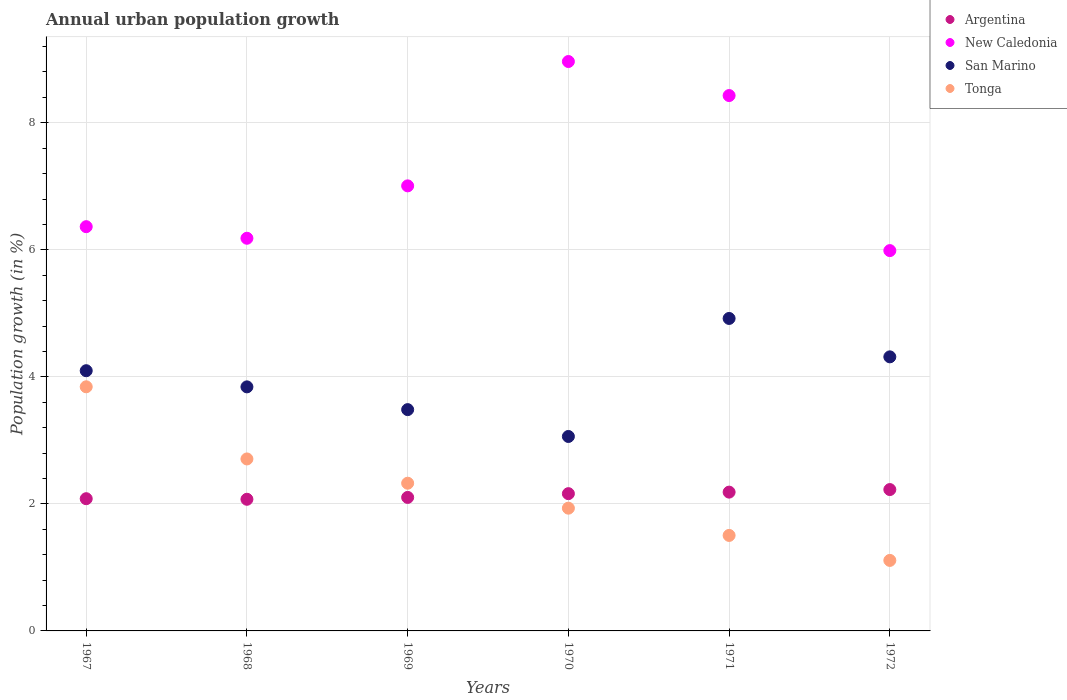Is the number of dotlines equal to the number of legend labels?
Make the answer very short. Yes. What is the percentage of urban population growth in Tonga in 1971?
Ensure brevity in your answer.  1.5. Across all years, what is the maximum percentage of urban population growth in Argentina?
Your response must be concise. 2.23. Across all years, what is the minimum percentage of urban population growth in Tonga?
Ensure brevity in your answer.  1.11. In which year was the percentage of urban population growth in Argentina maximum?
Your answer should be compact. 1972. In which year was the percentage of urban population growth in New Caledonia minimum?
Your answer should be compact. 1972. What is the total percentage of urban population growth in New Caledonia in the graph?
Make the answer very short. 42.93. What is the difference between the percentage of urban population growth in San Marino in 1968 and that in 1970?
Make the answer very short. 0.78. What is the difference between the percentage of urban population growth in New Caledonia in 1971 and the percentage of urban population growth in Argentina in 1970?
Provide a short and direct response. 6.27. What is the average percentage of urban population growth in Argentina per year?
Offer a terse response. 2.14. In the year 1968, what is the difference between the percentage of urban population growth in Tonga and percentage of urban population growth in Argentina?
Your response must be concise. 0.64. What is the ratio of the percentage of urban population growth in New Caledonia in 1968 to that in 1971?
Provide a short and direct response. 0.73. Is the percentage of urban population growth in Argentina in 1968 less than that in 1972?
Give a very brief answer. Yes. Is the difference between the percentage of urban population growth in Tonga in 1967 and 1970 greater than the difference between the percentage of urban population growth in Argentina in 1967 and 1970?
Make the answer very short. Yes. What is the difference between the highest and the second highest percentage of urban population growth in San Marino?
Offer a very short reply. 0.6. What is the difference between the highest and the lowest percentage of urban population growth in Tonga?
Your answer should be very brief. 2.73. In how many years, is the percentage of urban population growth in New Caledonia greater than the average percentage of urban population growth in New Caledonia taken over all years?
Your answer should be compact. 2. Is it the case that in every year, the sum of the percentage of urban population growth in San Marino and percentage of urban population growth in New Caledonia  is greater than the percentage of urban population growth in Argentina?
Your answer should be compact. Yes. Does the percentage of urban population growth in Tonga monotonically increase over the years?
Your response must be concise. No. Is the percentage of urban population growth in New Caledonia strictly greater than the percentage of urban population growth in San Marino over the years?
Your answer should be compact. Yes. What is the difference between two consecutive major ticks on the Y-axis?
Make the answer very short. 2. Are the values on the major ticks of Y-axis written in scientific E-notation?
Your answer should be very brief. No. Does the graph contain any zero values?
Your answer should be compact. No. Does the graph contain grids?
Your answer should be compact. Yes. Where does the legend appear in the graph?
Make the answer very short. Top right. How many legend labels are there?
Provide a short and direct response. 4. What is the title of the graph?
Offer a terse response. Annual urban population growth. What is the label or title of the Y-axis?
Ensure brevity in your answer.  Population growth (in %). What is the Population growth (in %) in Argentina in 1967?
Provide a succinct answer. 2.08. What is the Population growth (in %) of New Caledonia in 1967?
Give a very brief answer. 6.36. What is the Population growth (in %) of San Marino in 1967?
Offer a very short reply. 4.1. What is the Population growth (in %) of Tonga in 1967?
Your response must be concise. 3.84. What is the Population growth (in %) in Argentina in 1968?
Provide a short and direct response. 2.07. What is the Population growth (in %) in New Caledonia in 1968?
Your answer should be compact. 6.18. What is the Population growth (in %) of San Marino in 1968?
Keep it short and to the point. 3.84. What is the Population growth (in %) of Tonga in 1968?
Offer a very short reply. 2.71. What is the Population growth (in %) in Argentina in 1969?
Your response must be concise. 2.1. What is the Population growth (in %) of New Caledonia in 1969?
Ensure brevity in your answer.  7.01. What is the Population growth (in %) of San Marino in 1969?
Ensure brevity in your answer.  3.48. What is the Population growth (in %) in Tonga in 1969?
Offer a terse response. 2.33. What is the Population growth (in %) in Argentina in 1970?
Make the answer very short. 2.16. What is the Population growth (in %) in New Caledonia in 1970?
Provide a succinct answer. 8.96. What is the Population growth (in %) in San Marino in 1970?
Provide a short and direct response. 3.06. What is the Population growth (in %) in Tonga in 1970?
Provide a succinct answer. 1.93. What is the Population growth (in %) in Argentina in 1971?
Keep it short and to the point. 2.19. What is the Population growth (in %) of New Caledonia in 1971?
Provide a short and direct response. 8.43. What is the Population growth (in %) of San Marino in 1971?
Provide a succinct answer. 4.92. What is the Population growth (in %) of Tonga in 1971?
Give a very brief answer. 1.5. What is the Population growth (in %) of Argentina in 1972?
Ensure brevity in your answer.  2.23. What is the Population growth (in %) of New Caledonia in 1972?
Provide a short and direct response. 5.99. What is the Population growth (in %) of San Marino in 1972?
Your answer should be very brief. 4.31. What is the Population growth (in %) in Tonga in 1972?
Your response must be concise. 1.11. Across all years, what is the maximum Population growth (in %) of Argentina?
Provide a short and direct response. 2.23. Across all years, what is the maximum Population growth (in %) in New Caledonia?
Provide a short and direct response. 8.96. Across all years, what is the maximum Population growth (in %) of San Marino?
Your answer should be compact. 4.92. Across all years, what is the maximum Population growth (in %) of Tonga?
Ensure brevity in your answer.  3.84. Across all years, what is the minimum Population growth (in %) of Argentina?
Your response must be concise. 2.07. Across all years, what is the minimum Population growth (in %) in New Caledonia?
Your answer should be very brief. 5.99. Across all years, what is the minimum Population growth (in %) in San Marino?
Give a very brief answer. 3.06. Across all years, what is the minimum Population growth (in %) in Tonga?
Make the answer very short. 1.11. What is the total Population growth (in %) in Argentina in the graph?
Make the answer very short. 12.83. What is the total Population growth (in %) in New Caledonia in the graph?
Provide a succinct answer. 42.93. What is the total Population growth (in %) in San Marino in the graph?
Offer a very short reply. 23.72. What is the total Population growth (in %) of Tonga in the graph?
Offer a very short reply. 13.42. What is the difference between the Population growth (in %) in Argentina in 1967 and that in 1968?
Your answer should be compact. 0.01. What is the difference between the Population growth (in %) of New Caledonia in 1967 and that in 1968?
Make the answer very short. 0.18. What is the difference between the Population growth (in %) in San Marino in 1967 and that in 1968?
Ensure brevity in your answer.  0.25. What is the difference between the Population growth (in %) in Tonga in 1967 and that in 1968?
Provide a succinct answer. 1.14. What is the difference between the Population growth (in %) of Argentina in 1967 and that in 1969?
Offer a very short reply. -0.02. What is the difference between the Population growth (in %) of New Caledonia in 1967 and that in 1969?
Provide a short and direct response. -0.64. What is the difference between the Population growth (in %) in San Marino in 1967 and that in 1969?
Offer a terse response. 0.61. What is the difference between the Population growth (in %) in Tonga in 1967 and that in 1969?
Make the answer very short. 1.52. What is the difference between the Population growth (in %) in Argentina in 1967 and that in 1970?
Your answer should be very brief. -0.08. What is the difference between the Population growth (in %) in New Caledonia in 1967 and that in 1970?
Provide a short and direct response. -2.6. What is the difference between the Population growth (in %) of San Marino in 1967 and that in 1970?
Keep it short and to the point. 1.04. What is the difference between the Population growth (in %) in Tonga in 1967 and that in 1970?
Ensure brevity in your answer.  1.91. What is the difference between the Population growth (in %) of Argentina in 1967 and that in 1971?
Keep it short and to the point. -0.1. What is the difference between the Population growth (in %) of New Caledonia in 1967 and that in 1971?
Offer a very short reply. -2.06. What is the difference between the Population growth (in %) in San Marino in 1967 and that in 1971?
Your answer should be compact. -0.82. What is the difference between the Population growth (in %) in Tonga in 1967 and that in 1971?
Your answer should be compact. 2.34. What is the difference between the Population growth (in %) of Argentina in 1967 and that in 1972?
Your answer should be very brief. -0.14. What is the difference between the Population growth (in %) in New Caledonia in 1967 and that in 1972?
Offer a terse response. 0.38. What is the difference between the Population growth (in %) of San Marino in 1967 and that in 1972?
Your response must be concise. -0.22. What is the difference between the Population growth (in %) of Tonga in 1967 and that in 1972?
Offer a terse response. 2.73. What is the difference between the Population growth (in %) in Argentina in 1968 and that in 1969?
Your answer should be compact. -0.03. What is the difference between the Population growth (in %) of New Caledonia in 1968 and that in 1969?
Ensure brevity in your answer.  -0.82. What is the difference between the Population growth (in %) in San Marino in 1968 and that in 1969?
Give a very brief answer. 0.36. What is the difference between the Population growth (in %) of Tonga in 1968 and that in 1969?
Give a very brief answer. 0.38. What is the difference between the Population growth (in %) of Argentina in 1968 and that in 1970?
Offer a very short reply. -0.09. What is the difference between the Population growth (in %) in New Caledonia in 1968 and that in 1970?
Your answer should be compact. -2.78. What is the difference between the Population growth (in %) of San Marino in 1968 and that in 1970?
Your response must be concise. 0.78. What is the difference between the Population growth (in %) of Tonga in 1968 and that in 1970?
Provide a succinct answer. 0.78. What is the difference between the Population growth (in %) in Argentina in 1968 and that in 1971?
Your answer should be compact. -0.11. What is the difference between the Population growth (in %) in New Caledonia in 1968 and that in 1971?
Make the answer very short. -2.25. What is the difference between the Population growth (in %) of San Marino in 1968 and that in 1971?
Your answer should be compact. -1.08. What is the difference between the Population growth (in %) in Tonga in 1968 and that in 1971?
Ensure brevity in your answer.  1.2. What is the difference between the Population growth (in %) of Argentina in 1968 and that in 1972?
Keep it short and to the point. -0.15. What is the difference between the Population growth (in %) in New Caledonia in 1968 and that in 1972?
Your answer should be compact. 0.19. What is the difference between the Population growth (in %) of San Marino in 1968 and that in 1972?
Your answer should be compact. -0.47. What is the difference between the Population growth (in %) in Tonga in 1968 and that in 1972?
Keep it short and to the point. 1.6. What is the difference between the Population growth (in %) of Argentina in 1969 and that in 1970?
Offer a terse response. -0.06. What is the difference between the Population growth (in %) of New Caledonia in 1969 and that in 1970?
Your response must be concise. -1.96. What is the difference between the Population growth (in %) of San Marino in 1969 and that in 1970?
Give a very brief answer. 0.42. What is the difference between the Population growth (in %) of Tonga in 1969 and that in 1970?
Your answer should be compact. 0.39. What is the difference between the Population growth (in %) in Argentina in 1969 and that in 1971?
Provide a short and direct response. -0.08. What is the difference between the Population growth (in %) of New Caledonia in 1969 and that in 1971?
Give a very brief answer. -1.42. What is the difference between the Population growth (in %) in San Marino in 1969 and that in 1971?
Keep it short and to the point. -1.44. What is the difference between the Population growth (in %) of Tonga in 1969 and that in 1971?
Your response must be concise. 0.82. What is the difference between the Population growth (in %) in Argentina in 1969 and that in 1972?
Your answer should be compact. -0.12. What is the difference between the Population growth (in %) in New Caledonia in 1969 and that in 1972?
Offer a very short reply. 1.02. What is the difference between the Population growth (in %) of San Marino in 1969 and that in 1972?
Provide a short and direct response. -0.83. What is the difference between the Population growth (in %) in Tonga in 1969 and that in 1972?
Your answer should be very brief. 1.22. What is the difference between the Population growth (in %) of Argentina in 1970 and that in 1971?
Give a very brief answer. -0.02. What is the difference between the Population growth (in %) of New Caledonia in 1970 and that in 1971?
Your response must be concise. 0.54. What is the difference between the Population growth (in %) of San Marino in 1970 and that in 1971?
Provide a short and direct response. -1.86. What is the difference between the Population growth (in %) of Tonga in 1970 and that in 1971?
Ensure brevity in your answer.  0.43. What is the difference between the Population growth (in %) in Argentina in 1970 and that in 1972?
Your response must be concise. -0.06. What is the difference between the Population growth (in %) of New Caledonia in 1970 and that in 1972?
Your answer should be compact. 2.98. What is the difference between the Population growth (in %) of San Marino in 1970 and that in 1972?
Offer a very short reply. -1.25. What is the difference between the Population growth (in %) of Tonga in 1970 and that in 1972?
Ensure brevity in your answer.  0.82. What is the difference between the Population growth (in %) in Argentina in 1971 and that in 1972?
Make the answer very short. -0.04. What is the difference between the Population growth (in %) of New Caledonia in 1971 and that in 1972?
Give a very brief answer. 2.44. What is the difference between the Population growth (in %) of San Marino in 1971 and that in 1972?
Your response must be concise. 0.6. What is the difference between the Population growth (in %) in Tonga in 1971 and that in 1972?
Your answer should be compact. 0.39. What is the difference between the Population growth (in %) of Argentina in 1967 and the Population growth (in %) of New Caledonia in 1968?
Make the answer very short. -4.1. What is the difference between the Population growth (in %) in Argentina in 1967 and the Population growth (in %) in San Marino in 1968?
Make the answer very short. -1.76. What is the difference between the Population growth (in %) in Argentina in 1967 and the Population growth (in %) in Tonga in 1968?
Ensure brevity in your answer.  -0.63. What is the difference between the Population growth (in %) of New Caledonia in 1967 and the Population growth (in %) of San Marino in 1968?
Your answer should be very brief. 2.52. What is the difference between the Population growth (in %) of New Caledonia in 1967 and the Population growth (in %) of Tonga in 1968?
Ensure brevity in your answer.  3.66. What is the difference between the Population growth (in %) in San Marino in 1967 and the Population growth (in %) in Tonga in 1968?
Provide a short and direct response. 1.39. What is the difference between the Population growth (in %) in Argentina in 1967 and the Population growth (in %) in New Caledonia in 1969?
Offer a terse response. -4.93. What is the difference between the Population growth (in %) in Argentina in 1967 and the Population growth (in %) in San Marino in 1969?
Offer a very short reply. -1.4. What is the difference between the Population growth (in %) of Argentina in 1967 and the Population growth (in %) of Tonga in 1969?
Make the answer very short. -0.24. What is the difference between the Population growth (in %) of New Caledonia in 1967 and the Population growth (in %) of San Marino in 1969?
Make the answer very short. 2.88. What is the difference between the Population growth (in %) of New Caledonia in 1967 and the Population growth (in %) of Tonga in 1969?
Your answer should be compact. 4.04. What is the difference between the Population growth (in %) in San Marino in 1967 and the Population growth (in %) in Tonga in 1969?
Keep it short and to the point. 1.77. What is the difference between the Population growth (in %) of Argentina in 1967 and the Population growth (in %) of New Caledonia in 1970?
Give a very brief answer. -6.88. What is the difference between the Population growth (in %) in Argentina in 1967 and the Population growth (in %) in San Marino in 1970?
Make the answer very short. -0.98. What is the difference between the Population growth (in %) in Argentina in 1967 and the Population growth (in %) in Tonga in 1970?
Provide a succinct answer. 0.15. What is the difference between the Population growth (in %) of New Caledonia in 1967 and the Population growth (in %) of San Marino in 1970?
Ensure brevity in your answer.  3.3. What is the difference between the Population growth (in %) in New Caledonia in 1967 and the Population growth (in %) in Tonga in 1970?
Keep it short and to the point. 4.43. What is the difference between the Population growth (in %) in San Marino in 1967 and the Population growth (in %) in Tonga in 1970?
Ensure brevity in your answer.  2.16. What is the difference between the Population growth (in %) of Argentina in 1967 and the Population growth (in %) of New Caledonia in 1971?
Keep it short and to the point. -6.35. What is the difference between the Population growth (in %) of Argentina in 1967 and the Population growth (in %) of San Marino in 1971?
Your answer should be very brief. -2.84. What is the difference between the Population growth (in %) of Argentina in 1967 and the Population growth (in %) of Tonga in 1971?
Make the answer very short. 0.58. What is the difference between the Population growth (in %) in New Caledonia in 1967 and the Population growth (in %) in San Marino in 1971?
Provide a short and direct response. 1.44. What is the difference between the Population growth (in %) of New Caledonia in 1967 and the Population growth (in %) of Tonga in 1971?
Provide a succinct answer. 4.86. What is the difference between the Population growth (in %) in San Marino in 1967 and the Population growth (in %) in Tonga in 1971?
Provide a succinct answer. 2.59. What is the difference between the Population growth (in %) in Argentina in 1967 and the Population growth (in %) in New Caledonia in 1972?
Offer a very short reply. -3.91. What is the difference between the Population growth (in %) of Argentina in 1967 and the Population growth (in %) of San Marino in 1972?
Offer a terse response. -2.23. What is the difference between the Population growth (in %) of Argentina in 1967 and the Population growth (in %) of Tonga in 1972?
Make the answer very short. 0.97. What is the difference between the Population growth (in %) in New Caledonia in 1967 and the Population growth (in %) in San Marino in 1972?
Make the answer very short. 2.05. What is the difference between the Population growth (in %) in New Caledonia in 1967 and the Population growth (in %) in Tonga in 1972?
Your answer should be compact. 5.25. What is the difference between the Population growth (in %) of San Marino in 1967 and the Population growth (in %) of Tonga in 1972?
Provide a succinct answer. 2.99. What is the difference between the Population growth (in %) of Argentina in 1968 and the Population growth (in %) of New Caledonia in 1969?
Provide a short and direct response. -4.93. What is the difference between the Population growth (in %) of Argentina in 1968 and the Population growth (in %) of San Marino in 1969?
Offer a very short reply. -1.41. What is the difference between the Population growth (in %) in Argentina in 1968 and the Population growth (in %) in Tonga in 1969?
Offer a very short reply. -0.25. What is the difference between the Population growth (in %) of New Caledonia in 1968 and the Population growth (in %) of San Marino in 1969?
Offer a terse response. 2.7. What is the difference between the Population growth (in %) of New Caledonia in 1968 and the Population growth (in %) of Tonga in 1969?
Offer a terse response. 3.86. What is the difference between the Population growth (in %) of San Marino in 1968 and the Population growth (in %) of Tonga in 1969?
Give a very brief answer. 1.52. What is the difference between the Population growth (in %) of Argentina in 1968 and the Population growth (in %) of New Caledonia in 1970?
Provide a short and direct response. -6.89. What is the difference between the Population growth (in %) of Argentina in 1968 and the Population growth (in %) of San Marino in 1970?
Provide a short and direct response. -0.99. What is the difference between the Population growth (in %) of Argentina in 1968 and the Population growth (in %) of Tonga in 1970?
Keep it short and to the point. 0.14. What is the difference between the Population growth (in %) in New Caledonia in 1968 and the Population growth (in %) in San Marino in 1970?
Ensure brevity in your answer.  3.12. What is the difference between the Population growth (in %) in New Caledonia in 1968 and the Population growth (in %) in Tonga in 1970?
Keep it short and to the point. 4.25. What is the difference between the Population growth (in %) in San Marino in 1968 and the Population growth (in %) in Tonga in 1970?
Offer a very short reply. 1.91. What is the difference between the Population growth (in %) in Argentina in 1968 and the Population growth (in %) in New Caledonia in 1971?
Offer a terse response. -6.36. What is the difference between the Population growth (in %) of Argentina in 1968 and the Population growth (in %) of San Marino in 1971?
Your answer should be very brief. -2.85. What is the difference between the Population growth (in %) of Argentina in 1968 and the Population growth (in %) of Tonga in 1971?
Offer a very short reply. 0.57. What is the difference between the Population growth (in %) of New Caledonia in 1968 and the Population growth (in %) of San Marino in 1971?
Make the answer very short. 1.26. What is the difference between the Population growth (in %) in New Caledonia in 1968 and the Population growth (in %) in Tonga in 1971?
Keep it short and to the point. 4.68. What is the difference between the Population growth (in %) of San Marino in 1968 and the Population growth (in %) of Tonga in 1971?
Ensure brevity in your answer.  2.34. What is the difference between the Population growth (in %) of Argentina in 1968 and the Population growth (in %) of New Caledonia in 1972?
Your answer should be very brief. -3.92. What is the difference between the Population growth (in %) in Argentina in 1968 and the Population growth (in %) in San Marino in 1972?
Provide a succinct answer. -2.24. What is the difference between the Population growth (in %) in Argentina in 1968 and the Population growth (in %) in Tonga in 1972?
Give a very brief answer. 0.96. What is the difference between the Population growth (in %) of New Caledonia in 1968 and the Population growth (in %) of San Marino in 1972?
Give a very brief answer. 1.87. What is the difference between the Population growth (in %) of New Caledonia in 1968 and the Population growth (in %) of Tonga in 1972?
Provide a succinct answer. 5.07. What is the difference between the Population growth (in %) in San Marino in 1968 and the Population growth (in %) in Tonga in 1972?
Your answer should be compact. 2.73. What is the difference between the Population growth (in %) in Argentina in 1969 and the Population growth (in %) in New Caledonia in 1970?
Offer a very short reply. -6.86. What is the difference between the Population growth (in %) in Argentina in 1969 and the Population growth (in %) in San Marino in 1970?
Make the answer very short. -0.96. What is the difference between the Population growth (in %) of Argentina in 1969 and the Population growth (in %) of Tonga in 1970?
Make the answer very short. 0.17. What is the difference between the Population growth (in %) of New Caledonia in 1969 and the Population growth (in %) of San Marino in 1970?
Offer a terse response. 3.95. What is the difference between the Population growth (in %) of New Caledonia in 1969 and the Population growth (in %) of Tonga in 1970?
Provide a succinct answer. 5.07. What is the difference between the Population growth (in %) in San Marino in 1969 and the Population growth (in %) in Tonga in 1970?
Keep it short and to the point. 1.55. What is the difference between the Population growth (in %) in Argentina in 1969 and the Population growth (in %) in New Caledonia in 1971?
Give a very brief answer. -6.33. What is the difference between the Population growth (in %) of Argentina in 1969 and the Population growth (in %) of San Marino in 1971?
Give a very brief answer. -2.82. What is the difference between the Population growth (in %) of Argentina in 1969 and the Population growth (in %) of Tonga in 1971?
Your response must be concise. 0.6. What is the difference between the Population growth (in %) of New Caledonia in 1969 and the Population growth (in %) of San Marino in 1971?
Your response must be concise. 2.09. What is the difference between the Population growth (in %) of New Caledonia in 1969 and the Population growth (in %) of Tonga in 1971?
Offer a terse response. 5.5. What is the difference between the Population growth (in %) in San Marino in 1969 and the Population growth (in %) in Tonga in 1971?
Keep it short and to the point. 1.98. What is the difference between the Population growth (in %) in Argentina in 1969 and the Population growth (in %) in New Caledonia in 1972?
Provide a short and direct response. -3.89. What is the difference between the Population growth (in %) in Argentina in 1969 and the Population growth (in %) in San Marino in 1972?
Provide a succinct answer. -2.21. What is the difference between the Population growth (in %) of Argentina in 1969 and the Population growth (in %) of Tonga in 1972?
Keep it short and to the point. 0.99. What is the difference between the Population growth (in %) of New Caledonia in 1969 and the Population growth (in %) of San Marino in 1972?
Give a very brief answer. 2.69. What is the difference between the Population growth (in %) in New Caledonia in 1969 and the Population growth (in %) in Tonga in 1972?
Your answer should be very brief. 5.9. What is the difference between the Population growth (in %) in San Marino in 1969 and the Population growth (in %) in Tonga in 1972?
Make the answer very short. 2.37. What is the difference between the Population growth (in %) of Argentina in 1970 and the Population growth (in %) of New Caledonia in 1971?
Keep it short and to the point. -6.27. What is the difference between the Population growth (in %) of Argentina in 1970 and the Population growth (in %) of San Marino in 1971?
Make the answer very short. -2.76. What is the difference between the Population growth (in %) in Argentina in 1970 and the Population growth (in %) in Tonga in 1971?
Your answer should be very brief. 0.66. What is the difference between the Population growth (in %) in New Caledonia in 1970 and the Population growth (in %) in San Marino in 1971?
Provide a short and direct response. 4.05. What is the difference between the Population growth (in %) of New Caledonia in 1970 and the Population growth (in %) of Tonga in 1971?
Offer a very short reply. 7.46. What is the difference between the Population growth (in %) of San Marino in 1970 and the Population growth (in %) of Tonga in 1971?
Your answer should be very brief. 1.56. What is the difference between the Population growth (in %) in Argentina in 1970 and the Population growth (in %) in New Caledonia in 1972?
Provide a succinct answer. -3.83. What is the difference between the Population growth (in %) in Argentina in 1970 and the Population growth (in %) in San Marino in 1972?
Provide a succinct answer. -2.15. What is the difference between the Population growth (in %) of Argentina in 1970 and the Population growth (in %) of Tonga in 1972?
Ensure brevity in your answer.  1.05. What is the difference between the Population growth (in %) in New Caledonia in 1970 and the Population growth (in %) in San Marino in 1972?
Keep it short and to the point. 4.65. What is the difference between the Population growth (in %) of New Caledonia in 1970 and the Population growth (in %) of Tonga in 1972?
Provide a succinct answer. 7.85. What is the difference between the Population growth (in %) in San Marino in 1970 and the Population growth (in %) in Tonga in 1972?
Keep it short and to the point. 1.95. What is the difference between the Population growth (in %) in Argentina in 1971 and the Population growth (in %) in New Caledonia in 1972?
Make the answer very short. -3.8. What is the difference between the Population growth (in %) of Argentina in 1971 and the Population growth (in %) of San Marino in 1972?
Provide a short and direct response. -2.13. What is the difference between the Population growth (in %) in Argentina in 1971 and the Population growth (in %) in Tonga in 1972?
Your answer should be very brief. 1.08. What is the difference between the Population growth (in %) of New Caledonia in 1971 and the Population growth (in %) of San Marino in 1972?
Give a very brief answer. 4.11. What is the difference between the Population growth (in %) in New Caledonia in 1971 and the Population growth (in %) in Tonga in 1972?
Ensure brevity in your answer.  7.32. What is the difference between the Population growth (in %) of San Marino in 1971 and the Population growth (in %) of Tonga in 1972?
Ensure brevity in your answer.  3.81. What is the average Population growth (in %) in Argentina per year?
Keep it short and to the point. 2.14. What is the average Population growth (in %) of New Caledonia per year?
Provide a short and direct response. 7.16. What is the average Population growth (in %) in San Marino per year?
Offer a very short reply. 3.95. What is the average Population growth (in %) of Tonga per year?
Ensure brevity in your answer.  2.24. In the year 1967, what is the difference between the Population growth (in %) of Argentina and Population growth (in %) of New Caledonia?
Make the answer very short. -4.28. In the year 1967, what is the difference between the Population growth (in %) of Argentina and Population growth (in %) of San Marino?
Provide a succinct answer. -2.02. In the year 1967, what is the difference between the Population growth (in %) in Argentina and Population growth (in %) in Tonga?
Your response must be concise. -1.76. In the year 1967, what is the difference between the Population growth (in %) of New Caledonia and Population growth (in %) of San Marino?
Your response must be concise. 2.27. In the year 1967, what is the difference between the Population growth (in %) of New Caledonia and Population growth (in %) of Tonga?
Give a very brief answer. 2.52. In the year 1967, what is the difference between the Population growth (in %) in San Marino and Population growth (in %) in Tonga?
Give a very brief answer. 0.25. In the year 1968, what is the difference between the Population growth (in %) in Argentina and Population growth (in %) in New Caledonia?
Give a very brief answer. -4.11. In the year 1968, what is the difference between the Population growth (in %) in Argentina and Population growth (in %) in San Marino?
Give a very brief answer. -1.77. In the year 1968, what is the difference between the Population growth (in %) of Argentina and Population growth (in %) of Tonga?
Offer a very short reply. -0.64. In the year 1968, what is the difference between the Population growth (in %) in New Caledonia and Population growth (in %) in San Marino?
Provide a short and direct response. 2.34. In the year 1968, what is the difference between the Population growth (in %) in New Caledonia and Population growth (in %) in Tonga?
Give a very brief answer. 3.47. In the year 1968, what is the difference between the Population growth (in %) of San Marino and Population growth (in %) of Tonga?
Your answer should be very brief. 1.13. In the year 1969, what is the difference between the Population growth (in %) of Argentina and Population growth (in %) of New Caledonia?
Keep it short and to the point. -4.91. In the year 1969, what is the difference between the Population growth (in %) in Argentina and Population growth (in %) in San Marino?
Provide a succinct answer. -1.38. In the year 1969, what is the difference between the Population growth (in %) in Argentina and Population growth (in %) in Tonga?
Ensure brevity in your answer.  -0.22. In the year 1969, what is the difference between the Population growth (in %) in New Caledonia and Population growth (in %) in San Marino?
Your answer should be compact. 3.52. In the year 1969, what is the difference between the Population growth (in %) of New Caledonia and Population growth (in %) of Tonga?
Ensure brevity in your answer.  4.68. In the year 1969, what is the difference between the Population growth (in %) of San Marino and Population growth (in %) of Tonga?
Provide a succinct answer. 1.16. In the year 1970, what is the difference between the Population growth (in %) of Argentina and Population growth (in %) of New Caledonia?
Ensure brevity in your answer.  -6.8. In the year 1970, what is the difference between the Population growth (in %) in Argentina and Population growth (in %) in San Marino?
Provide a succinct answer. -0.9. In the year 1970, what is the difference between the Population growth (in %) of Argentina and Population growth (in %) of Tonga?
Make the answer very short. 0.23. In the year 1970, what is the difference between the Population growth (in %) in New Caledonia and Population growth (in %) in San Marino?
Make the answer very short. 5.9. In the year 1970, what is the difference between the Population growth (in %) in New Caledonia and Population growth (in %) in Tonga?
Your answer should be compact. 7.03. In the year 1970, what is the difference between the Population growth (in %) of San Marino and Population growth (in %) of Tonga?
Your answer should be compact. 1.13. In the year 1971, what is the difference between the Population growth (in %) in Argentina and Population growth (in %) in New Caledonia?
Give a very brief answer. -6.24. In the year 1971, what is the difference between the Population growth (in %) in Argentina and Population growth (in %) in San Marino?
Ensure brevity in your answer.  -2.73. In the year 1971, what is the difference between the Population growth (in %) in Argentina and Population growth (in %) in Tonga?
Your response must be concise. 0.68. In the year 1971, what is the difference between the Population growth (in %) in New Caledonia and Population growth (in %) in San Marino?
Keep it short and to the point. 3.51. In the year 1971, what is the difference between the Population growth (in %) of New Caledonia and Population growth (in %) of Tonga?
Your answer should be very brief. 6.93. In the year 1971, what is the difference between the Population growth (in %) of San Marino and Population growth (in %) of Tonga?
Ensure brevity in your answer.  3.42. In the year 1972, what is the difference between the Population growth (in %) of Argentina and Population growth (in %) of New Caledonia?
Ensure brevity in your answer.  -3.76. In the year 1972, what is the difference between the Population growth (in %) in Argentina and Population growth (in %) in San Marino?
Your answer should be compact. -2.09. In the year 1972, what is the difference between the Population growth (in %) in Argentina and Population growth (in %) in Tonga?
Give a very brief answer. 1.12. In the year 1972, what is the difference between the Population growth (in %) in New Caledonia and Population growth (in %) in San Marino?
Your response must be concise. 1.67. In the year 1972, what is the difference between the Population growth (in %) of New Caledonia and Population growth (in %) of Tonga?
Offer a terse response. 4.88. In the year 1972, what is the difference between the Population growth (in %) of San Marino and Population growth (in %) of Tonga?
Keep it short and to the point. 3.2. What is the ratio of the Population growth (in %) of New Caledonia in 1967 to that in 1968?
Your answer should be very brief. 1.03. What is the ratio of the Population growth (in %) of San Marino in 1967 to that in 1968?
Your response must be concise. 1.07. What is the ratio of the Population growth (in %) of Tonga in 1967 to that in 1968?
Offer a very short reply. 1.42. What is the ratio of the Population growth (in %) in Argentina in 1967 to that in 1969?
Your answer should be very brief. 0.99. What is the ratio of the Population growth (in %) of New Caledonia in 1967 to that in 1969?
Your answer should be compact. 0.91. What is the ratio of the Population growth (in %) of San Marino in 1967 to that in 1969?
Offer a very short reply. 1.18. What is the ratio of the Population growth (in %) in Tonga in 1967 to that in 1969?
Make the answer very short. 1.65. What is the ratio of the Population growth (in %) of Argentina in 1967 to that in 1970?
Ensure brevity in your answer.  0.96. What is the ratio of the Population growth (in %) in New Caledonia in 1967 to that in 1970?
Your answer should be compact. 0.71. What is the ratio of the Population growth (in %) in San Marino in 1967 to that in 1970?
Give a very brief answer. 1.34. What is the ratio of the Population growth (in %) of Tonga in 1967 to that in 1970?
Your answer should be compact. 1.99. What is the ratio of the Population growth (in %) of Argentina in 1967 to that in 1971?
Give a very brief answer. 0.95. What is the ratio of the Population growth (in %) of New Caledonia in 1967 to that in 1971?
Provide a short and direct response. 0.76. What is the ratio of the Population growth (in %) of San Marino in 1967 to that in 1971?
Ensure brevity in your answer.  0.83. What is the ratio of the Population growth (in %) of Tonga in 1967 to that in 1971?
Your answer should be compact. 2.56. What is the ratio of the Population growth (in %) in Argentina in 1967 to that in 1972?
Make the answer very short. 0.94. What is the ratio of the Population growth (in %) in New Caledonia in 1967 to that in 1972?
Keep it short and to the point. 1.06. What is the ratio of the Population growth (in %) of San Marino in 1967 to that in 1972?
Keep it short and to the point. 0.95. What is the ratio of the Population growth (in %) of Tonga in 1967 to that in 1972?
Your answer should be very brief. 3.46. What is the ratio of the Population growth (in %) in Argentina in 1968 to that in 1969?
Offer a terse response. 0.99. What is the ratio of the Population growth (in %) in New Caledonia in 1968 to that in 1969?
Your response must be concise. 0.88. What is the ratio of the Population growth (in %) in San Marino in 1968 to that in 1969?
Ensure brevity in your answer.  1.1. What is the ratio of the Population growth (in %) in Tonga in 1968 to that in 1969?
Make the answer very short. 1.16. What is the ratio of the Population growth (in %) in Argentina in 1968 to that in 1970?
Provide a short and direct response. 0.96. What is the ratio of the Population growth (in %) of New Caledonia in 1968 to that in 1970?
Your answer should be very brief. 0.69. What is the ratio of the Population growth (in %) of San Marino in 1968 to that in 1970?
Your answer should be very brief. 1.26. What is the ratio of the Population growth (in %) in Tonga in 1968 to that in 1970?
Keep it short and to the point. 1.4. What is the ratio of the Population growth (in %) of Argentina in 1968 to that in 1971?
Provide a short and direct response. 0.95. What is the ratio of the Population growth (in %) in New Caledonia in 1968 to that in 1971?
Your response must be concise. 0.73. What is the ratio of the Population growth (in %) of San Marino in 1968 to that in 1971?
Provide a succinct answer. 0.78. What is the ratio of the Population growth (in %) in Tonga in 1968 to that in 1971?
Keep it short and to the point. 1.8. What is the ratio of the Population growth (in %) in Argentina in 1968 to that in 1972?
Keep it short and to the point. 0.93. What is the ratio of the Population growth (in %) of New Caledonia in 1968 to that in 1972?
Make the answer very short. 1.03. What is the ratio of the Population growth (in %) of San Marino in 1968 to that in 1972?
Offer a very short reply. 0.89. What is the ratio of the Population growth (in %) in Tonga in 1968 to that in 1972?
Offer a very short reply. 2.44. What is the ratio of the Population growth (in %) in Argentina in 1969 to that in 1970?
Your answer should be compact. 0.97. What is the ratio of the Population growth (in %) in New Caledonia in 1969 to that in 1970?
Provide a succinct answer. 0.78. What is the ratio of the Population growth (in %) of San Marino in 1969 to that in 1970?
Give a very brief answer. 1.14. What is the ratio of the Population growth (in %) of Tonga in 1969 to that in 1970?
Give a very brief answer. 1.2. What is the ratio of the Population growth (in %) in Argentina in 1969 to that in 1971?
Provide a short and direct response. 0.96. What is the ratio of the Population growth (in %) of New Caledonia in 1969 to that in 1971?
Your response must be concise. 0.83. What is the ratio of the Population growth (in %) of San Marino in 1969 to that in 1971?
Give a very brief answer. 0.71. What is the ratio of the Population growth (in %) in Tonga in 1969 to that in 1971?
Offer a very short reply. 1.55. What is the ratio of the Population growth (in %) in Argentina in 1969 to that in 1972?
Your response must be concise. 0.94. What is the ratio of the Population growth (in %) of New Caledonia in 1969 to that in 1972?
Provide a succinct answer. 1.17. What is the ratio of the Population growth (in %) of San Marino in 1969 to that in 1972?
Give a very brief answer. 0.81. What is the ratio of the Population growth (in %) of Tonga in 1969 to that in 1972?
Your answer should be very brief. 2.09. What is the ratio of the Population growth (in %) in Argentina in 1970 to that in 1971?
Ensure brevity in your answer.  0.99. What is the ratio of the Population growth (in %) in New Caledonia in 1970 to that in 1971?
Offer a very short reply. 1.06. What is the ratio of the Population growth (in %) in San Marino in 1970 to that in 1971?
Make the answer very short. 0.62. What is the ratio of the Population growth (in %) of Tonga in 1970 to that in 1971?
Provide a succinct answer. 1.29. What is the ratio of the Population growth (in %) in Argentina in 1970 to that in 1972?
Offer a very short reply. 0.97. What is the ratio of the Population growth (in %) of New Caledonia in 1970 to that in 1972?
Ensure brevity in your answer.  1.5. What is the ratio of the Population growth (in %) of San Marino in 1970 to that in 1972?
Offer a very short reply. 0.71. What is the ratio of the Population growth (in %) in Tonga in 1970 to that in 1972?
Offer a terse response. 1.74. What is the ratio of the Population growth (in %) in Argentina in 1971 to that in 1972?
Ensure brevity in your answer.  0.98. What is the ratio of the Population growth (in %) of New Caledonia in 1971 to that in 1972?
Make the answer very short. 1.41. What is the ratio of the Population growth (in %) in San Marino in 1971 to that in 1972?
Your response must be concise. 1.14. What is the ratio of the Population growth (in %) of Tonga in 1971 to that in 1972?
Provide a succinct answer. 1.35. What is the difference between the highest and the second highest Population growth (in %) of Argentina?
Keep it short and to the point. 0.04. What is the difference between the highest and the second highest Population growth (in %) of New Caledonia?
Offer a terse response. 0.54. What is the difference between the highest and the second highest Population growth (in %) in San Marino?
Give a very brief answer. 0.6. What is the difference between the highest and the second highest Population growth (in %) of Tonga?
Your answer should be compact. 1.14. What is the difference between the highest and the lowest Population growth (in %) of Argentina?
Your answer should be very brief. 0.15. What is the difference between the highest and the lowest Population growth (in %) in New Caledonia?
Provide a short and direct response. 2.98. What is the difference between the highest and the lowest Population growth (in %) in San Marino?
Make the answer very short. 1.86. What is the difference between the highest and the lowest Population growth (in %) in Tonga?
Ensure brevity in your answer.  2.73. 